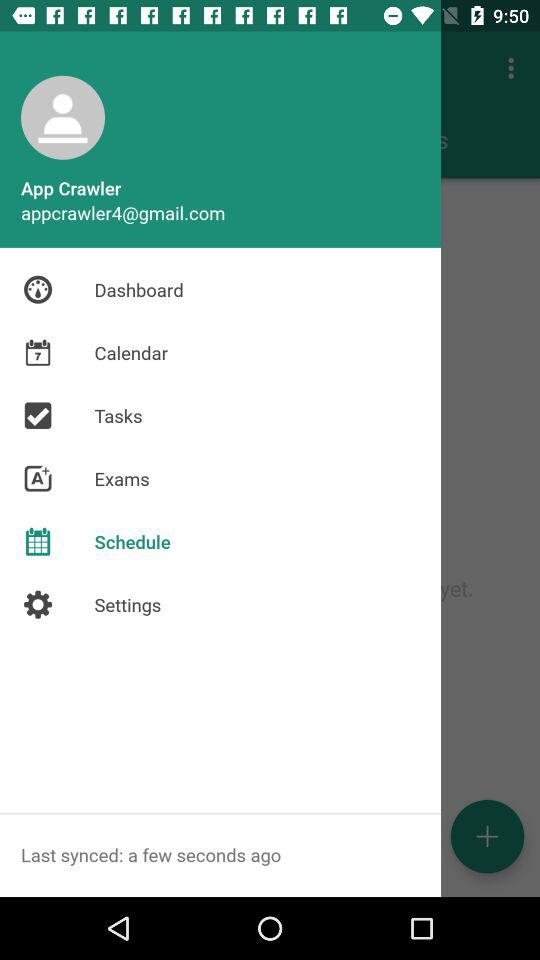What Gmail address is used? The used Gmail address is appcrawler4@gmail.com. 